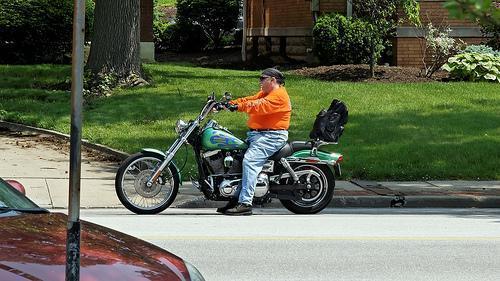How many wheels are shown?
Give a very brief answer. 2. 